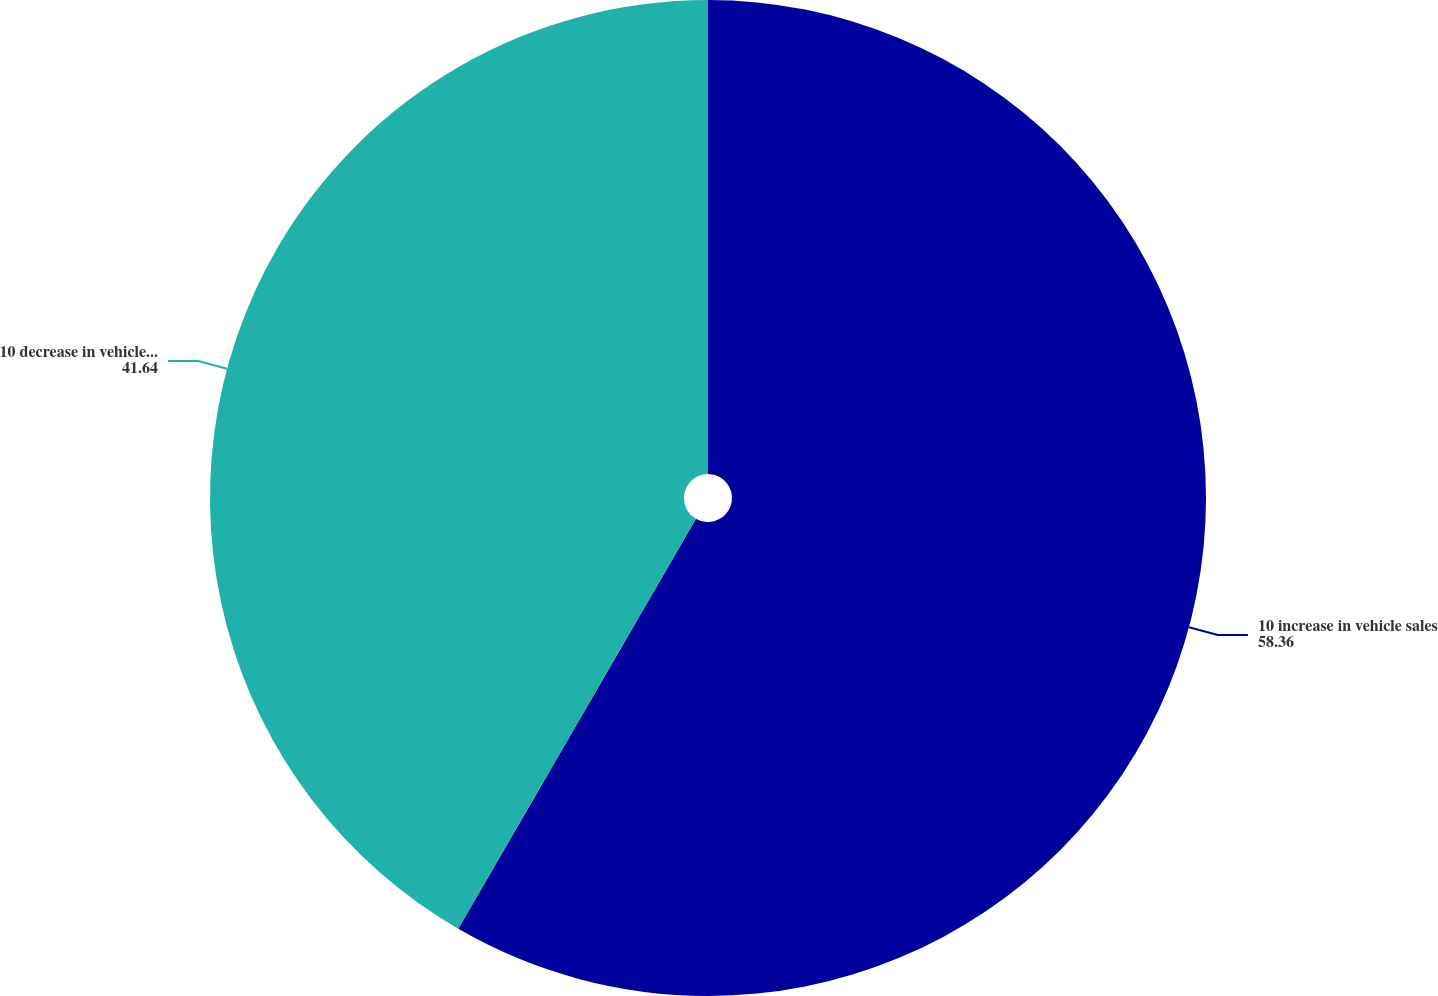<chart> <loc_0><loc_0><loc_500><loc_500><pie_chart><fcel>10 increase in vehicle sales<fcel>10 decrease in vehicle sales<nl><fcel>58.36%<fcel>41.64%<nl></chart> 